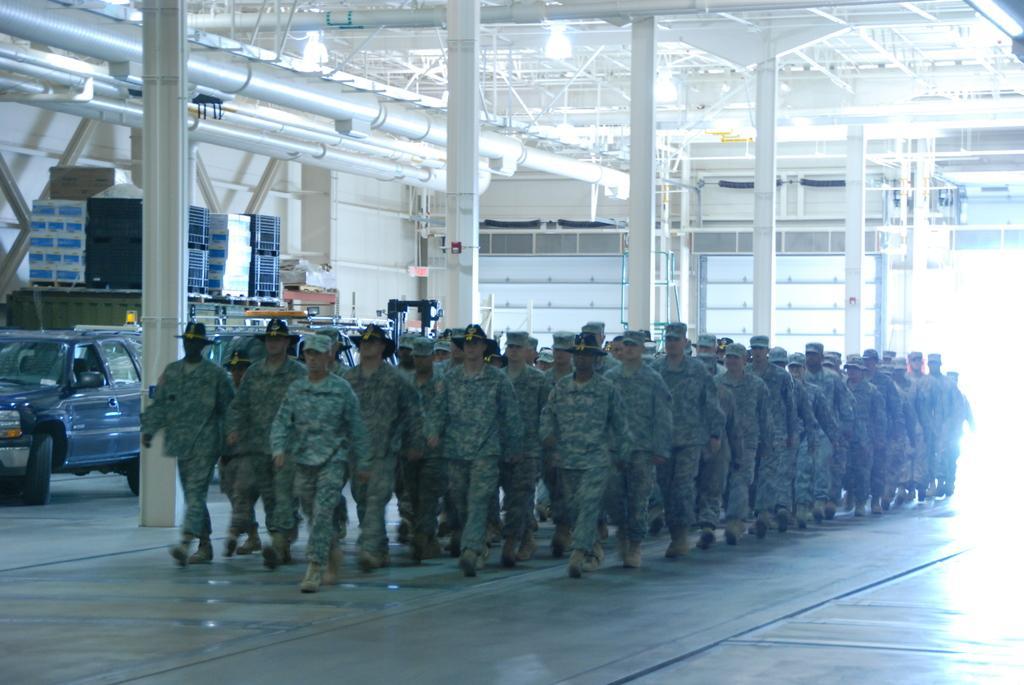Please provide a concise description of this image. In this image we can see a crowd walking on the floor wearing the uniform. In the background we can see motor vehicles on the floor, cartons, iron grills, electric lights and pipelines. 